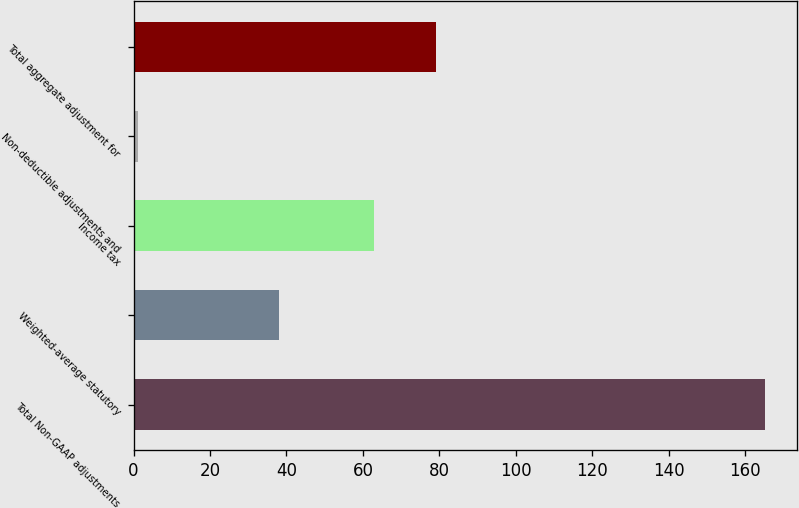Convert chart. <chart><loc_0><loc_0><loc_500><loc_500><bar_chart><fcel>Total Non-GAAP adjustments<fcel>Weighted-average statutory<fcel>Income tax<fcel>Non-deductible adjustments and<fcel>Total aggregate adjustment for<nl><fcel>165.2<fcel>38<fcel>62.8<fcel>1.3<fcel>79.19<nl></chart> 